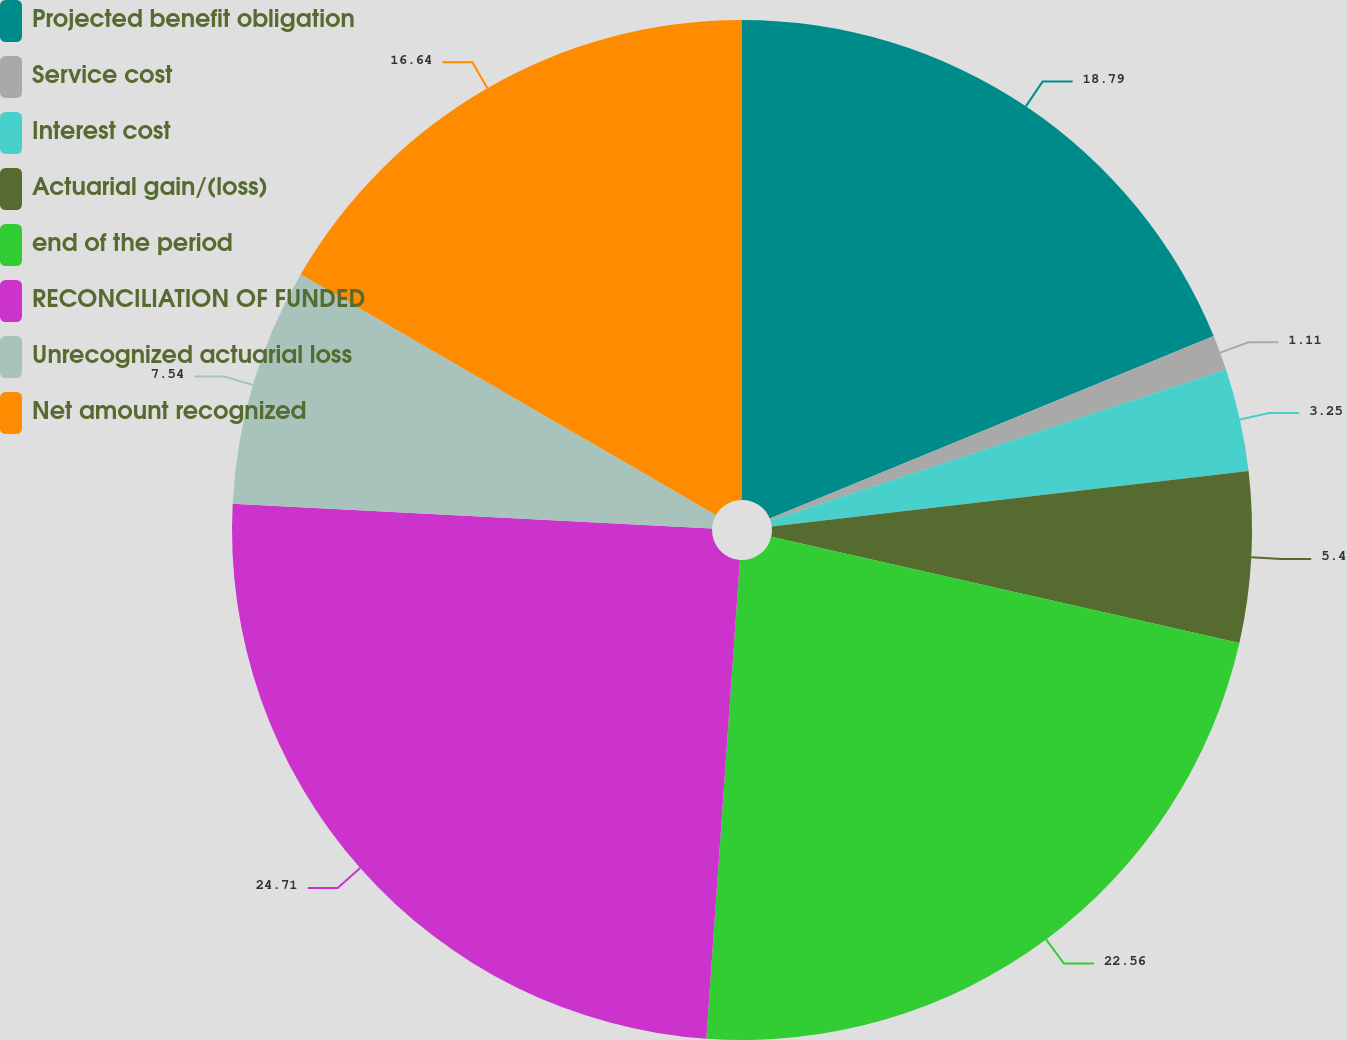Convert chart. <chart><loc_0><loc_0><loc_500><loc_500><pie_chart><fcel>Projected benefit obligation<fcel>Service cost<fcel>Interest cost<fcel>Actuarial gain/(loss)<fcel>end of the period<fcel>RECONCILIATION OF FUNDED<fcel>Unrecognized actuarial loss<fcel>Net amount recognized<nl><fcel>18.79%<fcel>1.11%<fcel>3.25%<fcel>5.4%<fcel>22.56%<fcel>24.7%<fcel>7.54%<fcel>16.64%<nl></chart> 